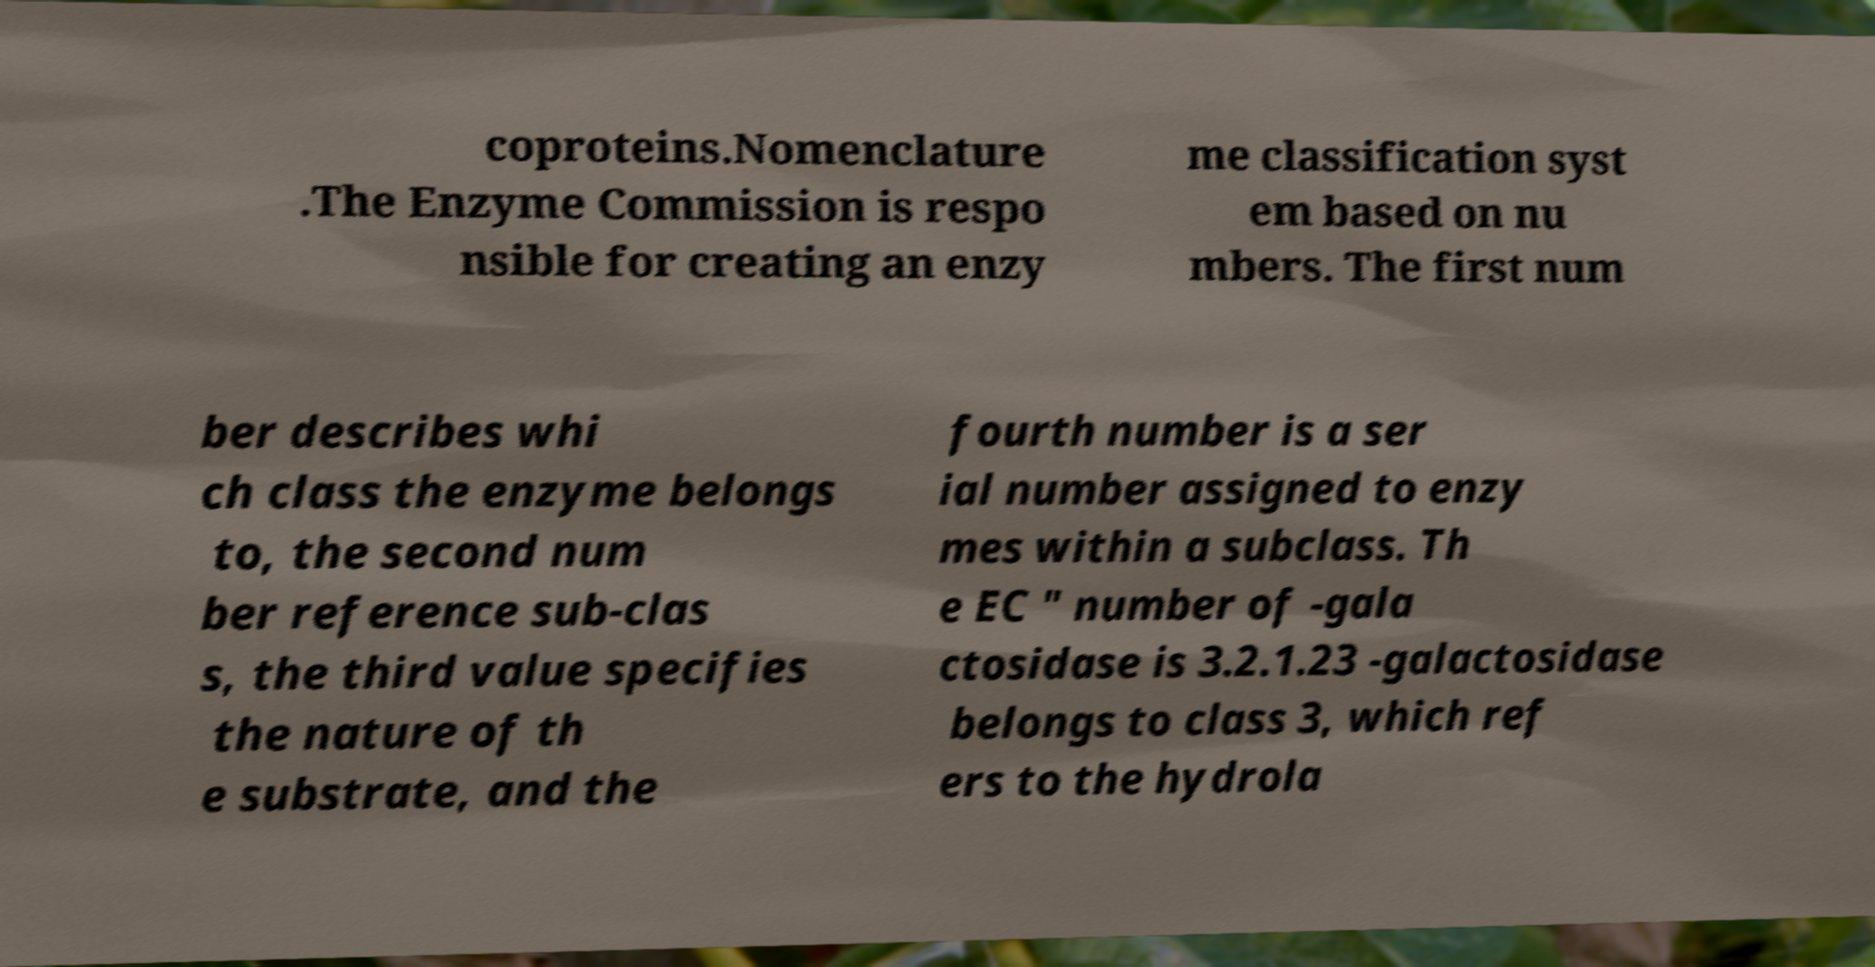There's text embedded in this image that I need extracted. Can you transcribe it verbatim? coproteins.Nomenclature .The Enzyme Commission is respo nsible for creating an enzy me classification syst em based on nu mbers. The first num ber describes whi ch class the enzyme belongs to, the second num ber reference sub-clas s, the third value specifies the nature of th e substrate, and the fourth number is a ser ial number assigned to enzy mes within a subclass. Th e EC " number of -gala ctosidase is 3.2.1.23 -galactosidase belongs to class 3, which ref ers to the hydrola 